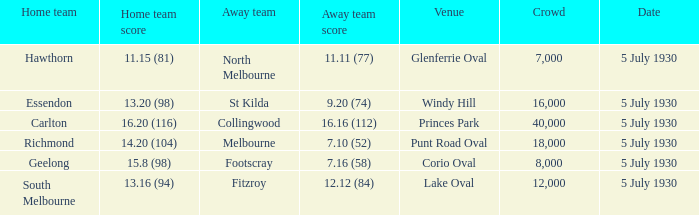What is the venue when fitzroy was the away team? Lake Oval. Would you mind parsing the complete table? {'header': ['Home team', 'Home team score', 'Away team', 'Away team score', 'Venue', 'Crowd', 'Date'], 'rows': [['Hawthorn', '11.15 (81)', 'North Melbourne', '11.11 (77)', 'Glenferrie Oval', '7,000', '5 July 1930'], ['Essendon', '13.20 (98)', 'St Kilda', '9.20 (74)', 'Windy Hill', '16,000', '5 July 1930'], ['Carlton', '16.20 (116)', 'Collingwood', '16.16 (112)', 'Princes Park', '40,000', '5 July 1930'], ['Richmond', '14.20 (104)', 'Melbourne', '7.10 (52)', 'Punt Road Oval', '18,000', '5 July 1930'], ['Geelong', '15.8 (98)', 'Footscray', '7.16 (58)', 'Corio Oval', '8,000', '5 July 1930'], ['South Melbourne', '13.16 (94)', 'Fitzroy', '12.12 (84)', 'Lake Oval', '12,000', '5 July 1930']]} 